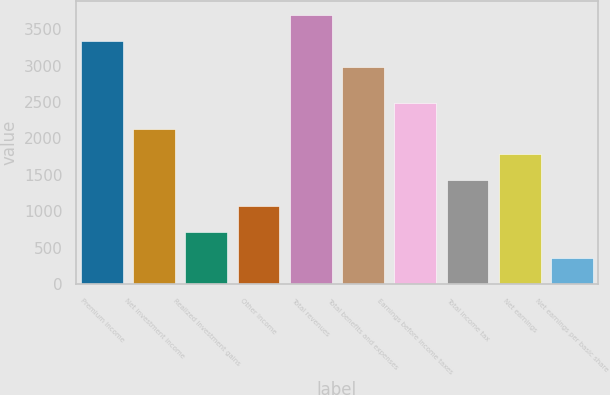Convert chart. <chart><loc_0><loc_0><loc_500><loc_500><bar_chart><fcel>Premium income<fcel>Net investment income<fcel>Realized investment gains<fcel>Other income<fcel>Total revenues<fcel>Total benefits and expenses<fcel>Earnings before income taxes<fcel>Total income tax<fcel>Net earnings<fcel>Net earnings per basic share<nl><fcel>3339.83<fcel>2135.72<fcel>712.4<fcel>1068.23<fcel>3695.66<fcel>2984<fcel>2491.55<fcel>1424.06<fcel>1779.89<fcel>356.57<nl></chart> 